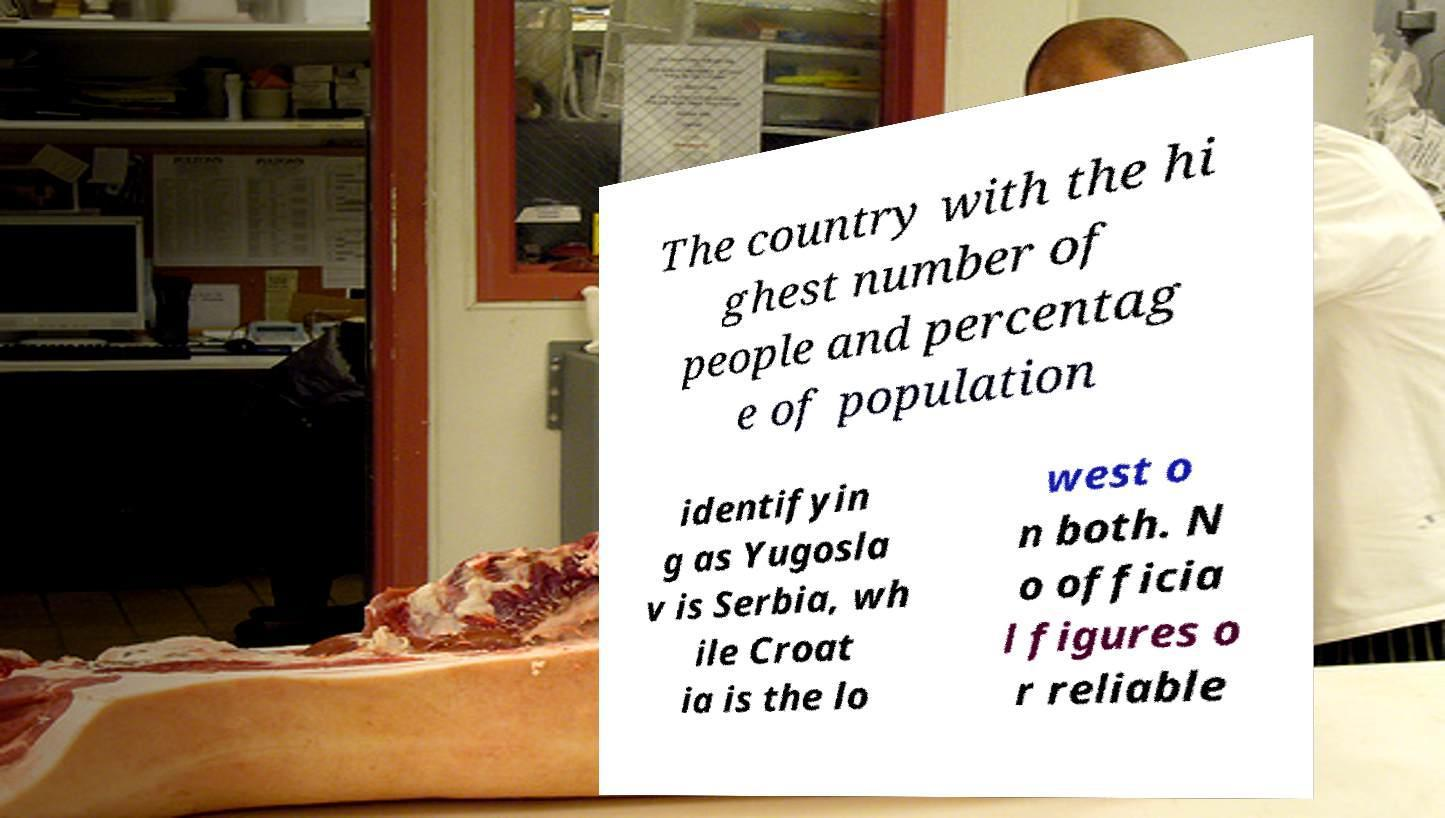There's text embedded in this image that I need extracted. Can you transcribe it verbatim? The country with the hi ghest number of people and percentag e of population identifyin g as Yugosla v is Serbia, wh ile Croat ia is the lo west o n both. N o officia l figures o r reliable 